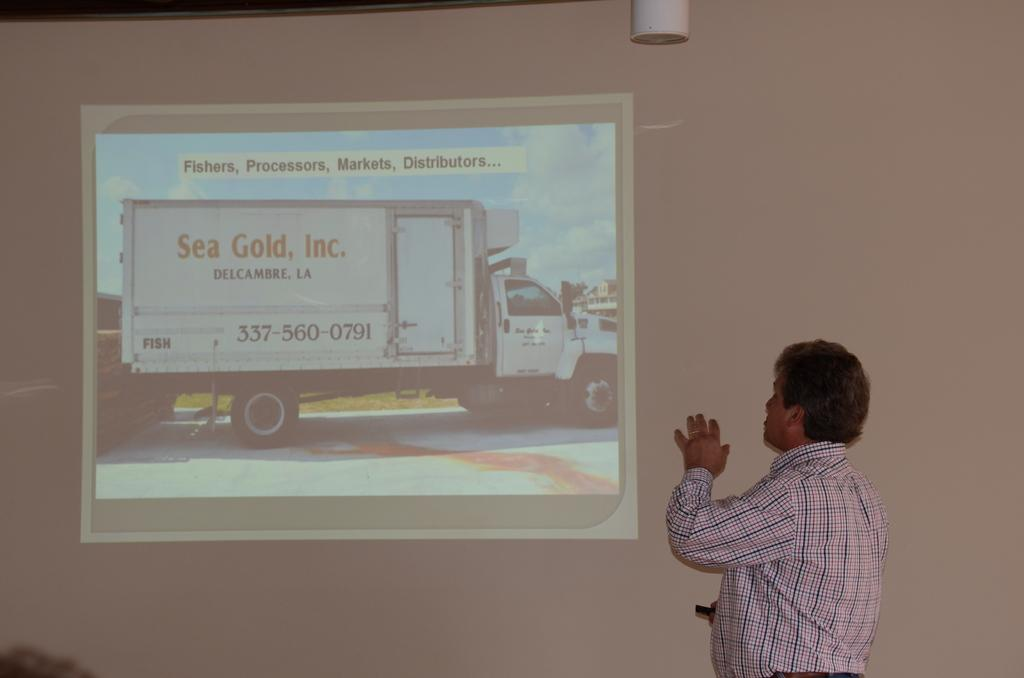What is the main subject of the image? There is a person standing in the image. What can be seen in the background of the image? There is a projector screen in the background of the image. What is being displayed on the projector screen? A presentation is visible on the projector screen. What type of vehicle is present in the image? There is a truck in the image. Are there any words or letters visible in the image? Yes, there is some text visible in the image. How many cakes are being served from the drawer in the image? There is no drawer or cakes present in the image. What type of zebra can be seen interacting with the truck in the image? There is no zebra present in the image; only a person, projector screen, presentation, and truck are visible. 